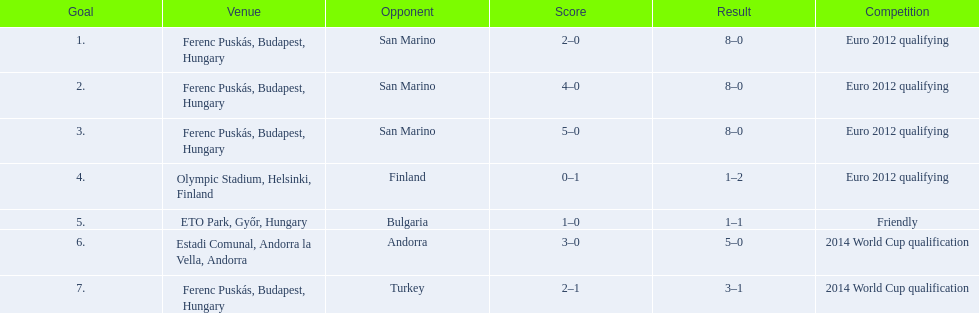What is the number of goals ádám szalai made against san marino in 2010? 3. 